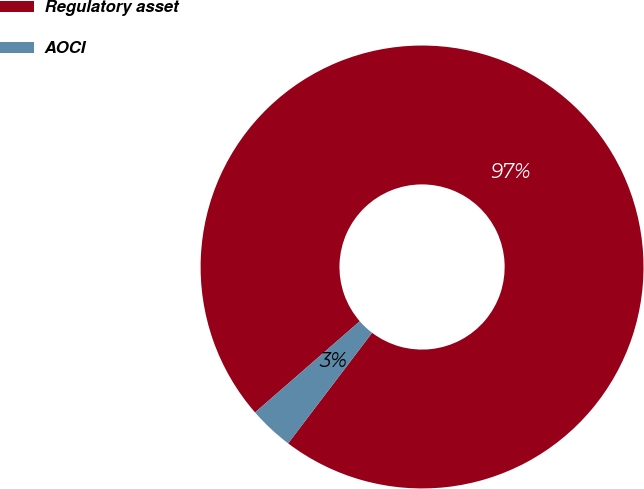<chart> <loc_0><loc_0><loc_500><loc_500><pie_chart><fcel>Regulatory asset<fcel>AOCI<nl><fcel>96.74%<fcel>3.26%<nl></chart> 